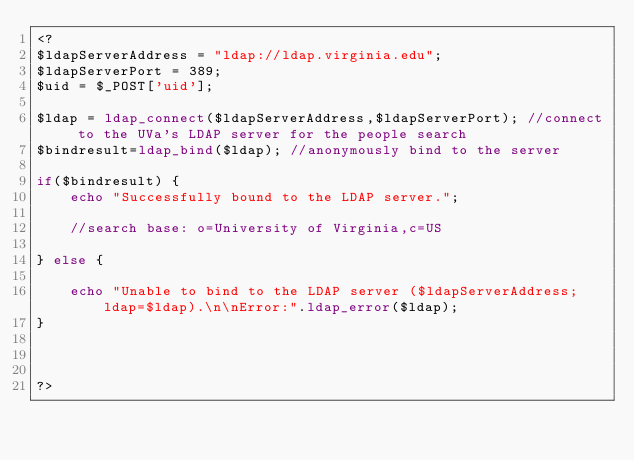<code> <loc_0><loc_0><loc_500><loc_500><_PHP_><?
$ldapServerAddress = "ldap://ldap.virginia.edu";
$ldapServerPort = 389;
$uid = $_POST['uid'];

$ldap = ldap_connect($ldapServerAddress,$ldapServerPort); //connect to the UVa's LDAP server for the people search
$bindresult=ldap_bind($ldap); //anonymously bind to the server

if($bindresult) {
	echo "Successfully bound to the LDAP server.";
	
	//search base: o=University of Virginia,c=US
	
} else {
	
	echo "Unable to bind to the LDAP server ($ldapServerAddress; ldap=$ldap).\n\nError:".ldap_error($ldap);
}



?></code> 